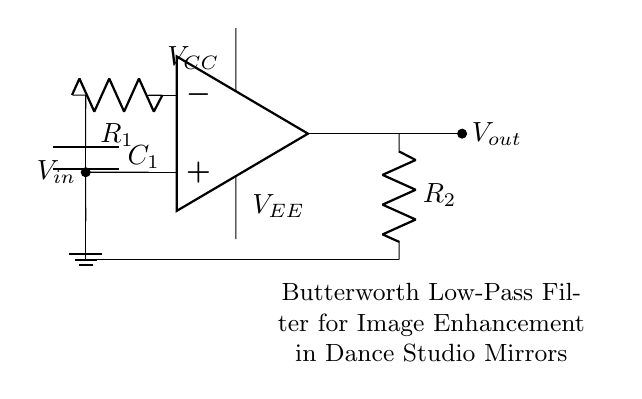What is the input voltage of the circuit? The input voltage is labeled as V_in in the circuit, which is the voltage supplied to the non-inverting terminal of the operational amplifier.
Answer: V_in What component is used for frequency response shaping? The circuit contains a capacitor, labeled as C_1, that, in conjunction with resistors, helps shape the frequency response of the circuit as a Butterworth filter.
Answer: C_1 How many resistors are present in the circuit? There are two resistors in the circuit, labeled as R_1 and R_2, which are used in the filtering process.
Answer: 2 What type of filter is implemented in this circuit? The circuit is a Butterworth low-pass filter, known for its maximally flat frequency response in the passband.
Answer: Butterworth low-pass filter What is the output voltage measurement point? The output voltage is measured at the point labeled V_out, which is taken directly from the output of the operational amplifier.
Answer: V_out Why does the capacitor connect to ground in this configuration? The capacitor connects to ground to form a low-pass filter configuration, allowing low-frequency signals to pass while attenuating high-frequency signals, effectively filtering the input.
Answer: To filter high frequencies What is the function of the operational amplifier in this circuit? The operational amplifier functions to amplify the input signal while incorporating the feedback from the resistors and capacitor in the circuit, aiding in the filtering process.
Answer: Amplification 